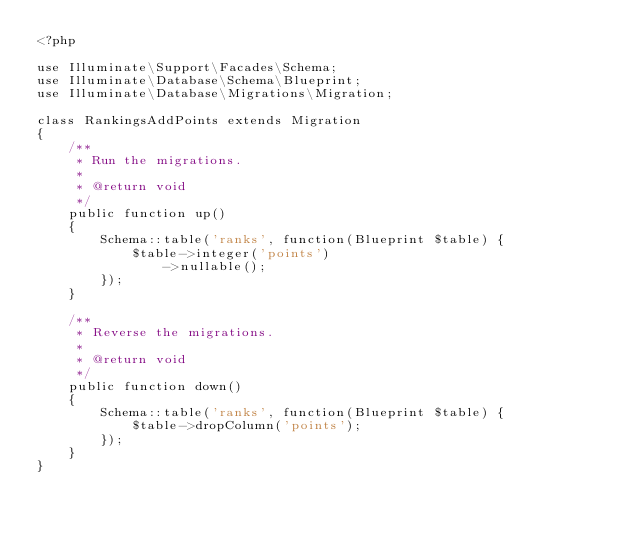Convert code to text. <code><loc_0><loc_0><loc_500><loc_500><_PHP_><?php

use Illuminate\Support\Facades\Schema;
use Illuminate\Database\Schema\Blueprint;
use Illuminate\Database\Migrations\Migration;

class RankingsAddPoints extends Migration
{
    /**
     * Run the migrations.
     *
     * @return void
     */
    public function up()
    {
        Schema::table('ranks', function(Blueprint $table) {
            $table->integer('points')
                ->nullable();
        });
    }

    /**
     * Reverse the migrations.
     *
     * @return void
     */
    public function down()
    {
        Schema::table('ranks', function(Blueprint $table) {
            $table->dropColumn('points');
        });
    }
}
</code> 